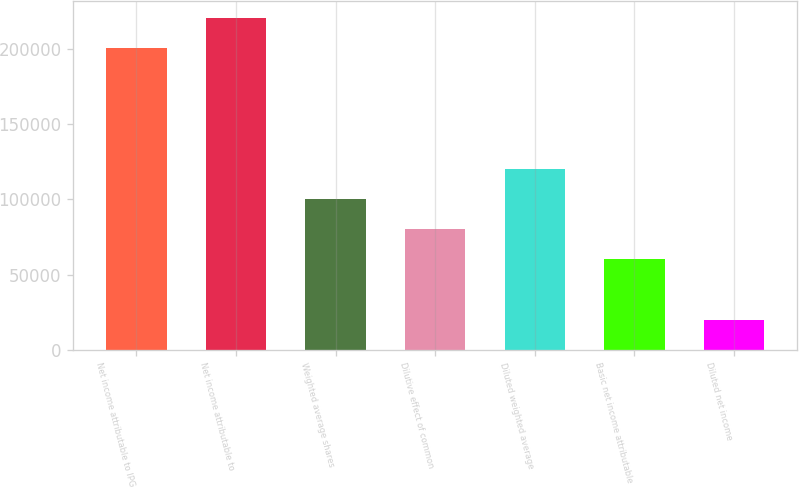<chart> <loc_0><loc_0><loc_500><loc_500><bar_chart><fcel>Net income attributable to IPG<fcel>Net income attributable to<fcel>Weighted average shares<fcel>Dilutive effect of common<fcel>Diluted weighted average<fcel>Basic net income attributable<fcel>Diluted net income<nl><fcel>200445<fcel>220489<fcel>100224<fcel>80180.3<fcel>120269<fcel>60136.2<fcel>20047.9<nl></chart> 